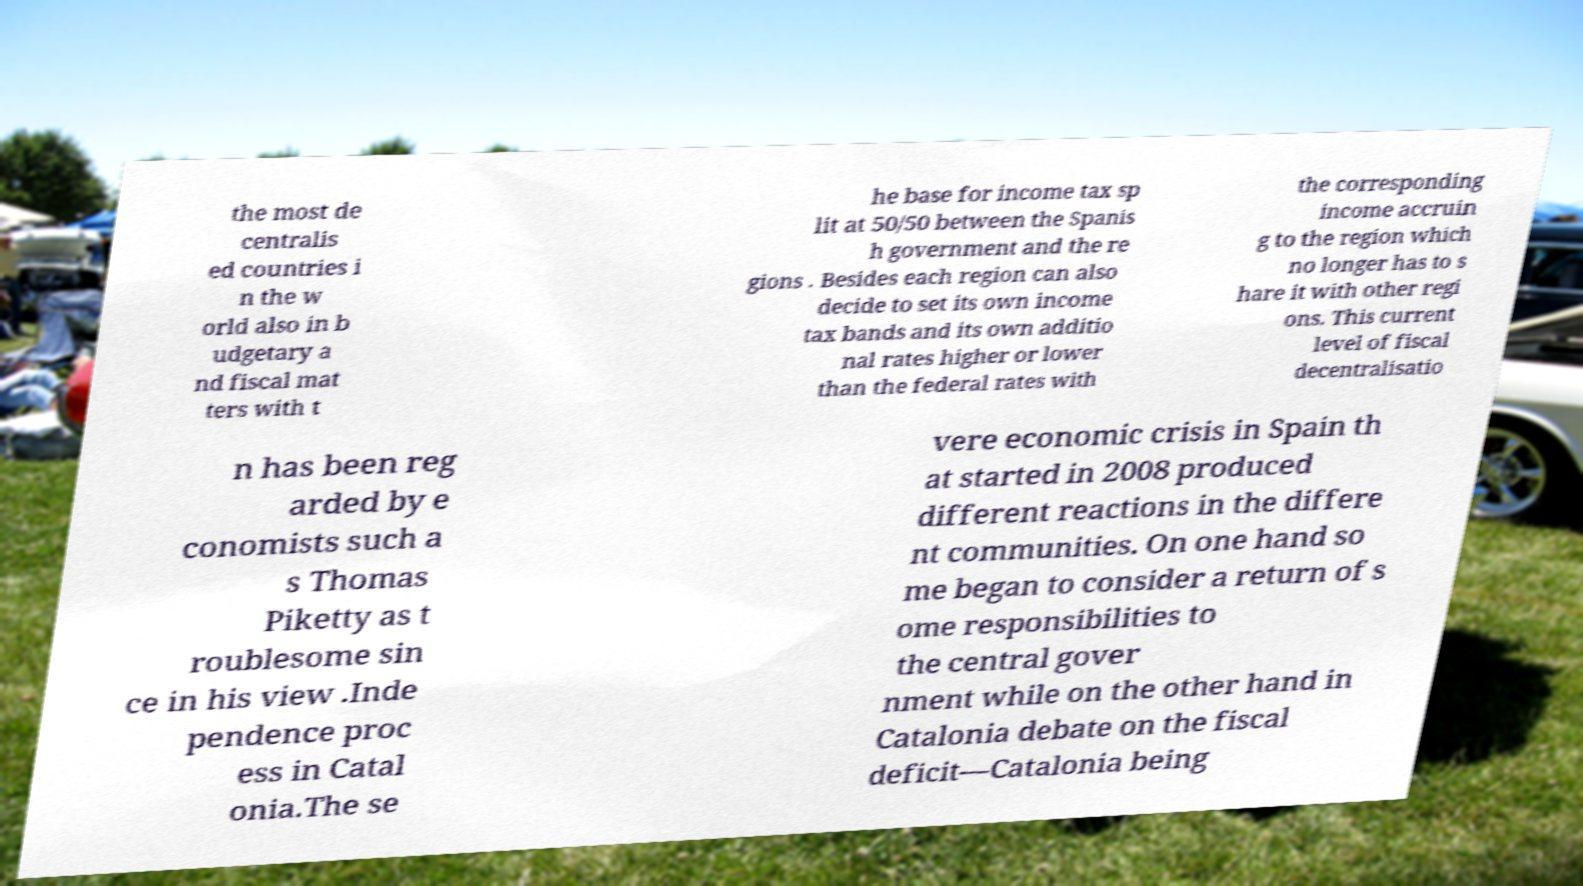Could you extract and type out the text from this image? the most de centralis ed countries i n the w orld also in b udgetary a nd fiscal mat ters with t he base for income tax sp lit at 50/50 between the Spanis h government and the re gions . Besides each region can also decide to set its own income tax bands and its own additio nal rates higher or lower than the federal rates with the corresponding income accruin g to the region which no longer has to s hare it with other regi ons. This current level of fiscal decentralisatio n has been reg arded by e conomists such a s Thomas Piketty as t roublesome sin ce in his view .Inde pendence proc ess in Catal onia.The se vere economic crisis in Spain th at started in 2008 produced different reactions in the differe nt communities. On one hand so me began to consider a return of s ome responsibilities to the central gover nment while on the other hand in Catalonia debate on the fiscal deficit—Catalonia being 